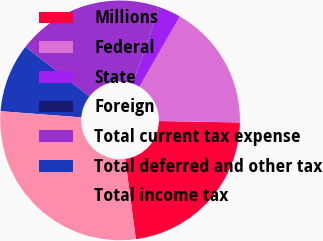Convert chart to OTSL. <chart><loc_0><loc_0><loc_500><loc_500><pie_chart><fcel>Millions<fcel>Federal<fcel>State<fcel>Foreign<fcel>Total current tax expense<fcel>Total deferred and other tax<fcel>Total income tax<nl><fcel>22.62%<fcel>16.97%<fcel>2.91%<fcel>0.09%<fcel>19.8%<fcel>9.29%<fcel>28.32%<nl></chart> 